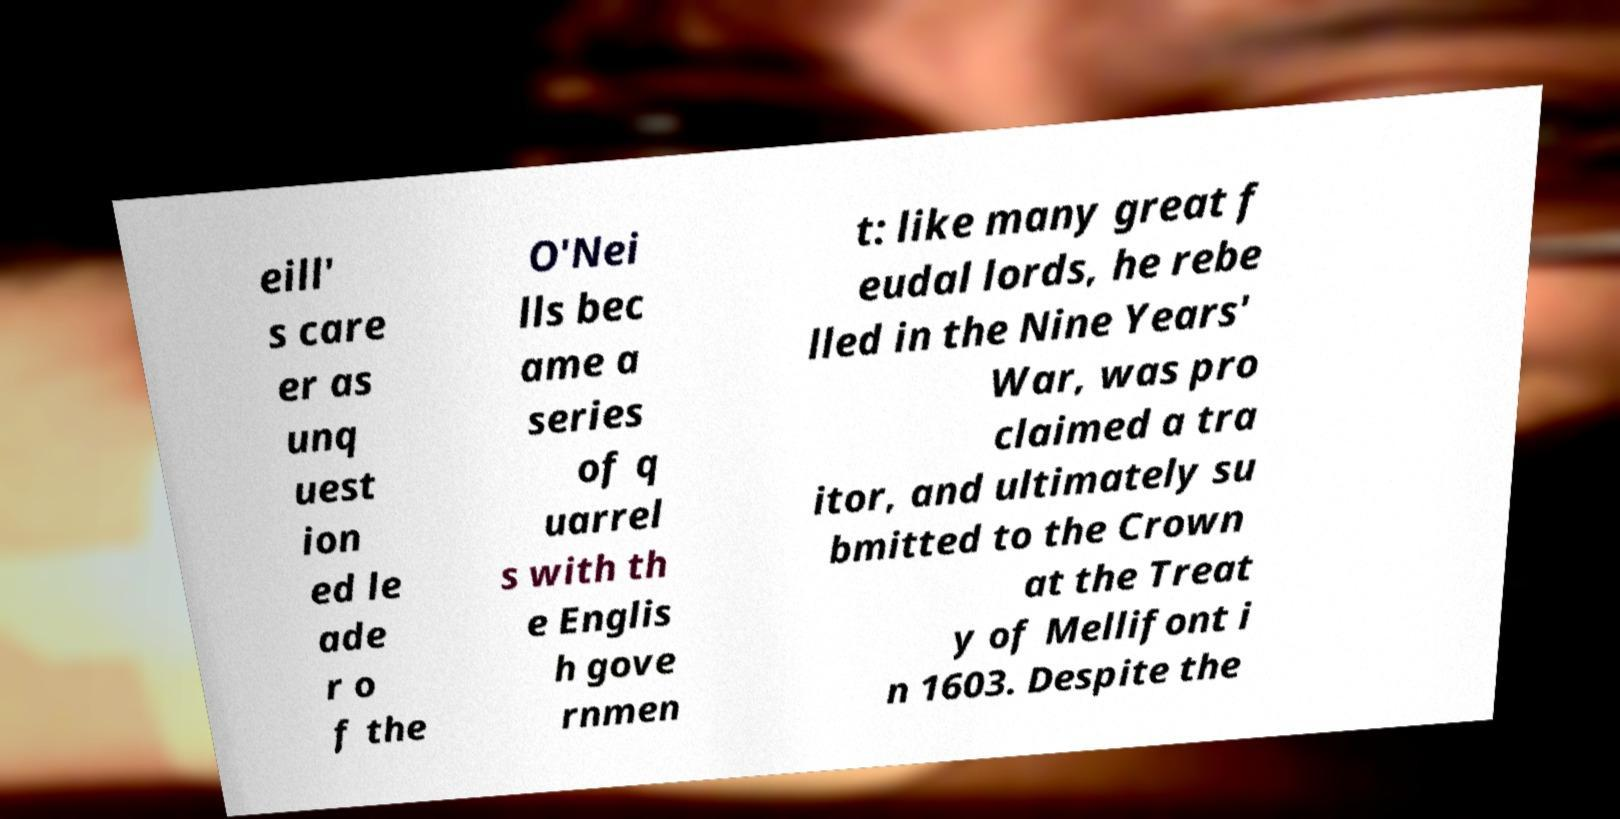I need the written content from this picture converted into text. Can you do that? eill' s care er as unq uest ion ed le ade r o f the O'Nei lls bec ame a series of q uarrel s with th e Englis h gove rnmen t: like many great f eudal lords, he rebe lled in the Nine Years' War, was pro claimed a tra itor, and ultimately su bmitted to the Crown at the Treat y of Mellifont i n 1603. Despite the 